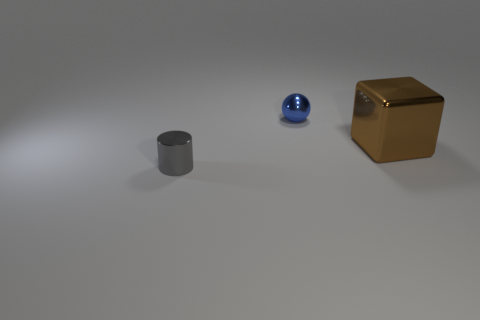Is there any other thing that has the same size as the brown shiny thing?
Provide a short and direct response. No. How many cylinders are either small gray objects or tiny yellow objects?
Provide a succinct answer. 1. The metal cube is what color?
Keep it short and to the point. Brown. How many things are metallic cubes or blue spheres?
Offer a very short reply. 2. There is a shiny object that is right of the metallic ball; what size is it?
Ensure brevity in your answer.  Large. How many objects are either small metallic objects in front of the small blue metallic ball or small objects in front of the tiny blue ball?
Your answer should be very brief. 1. What number of other things are the same color as the big block?
Provide a short and direct response. 0. Are there fewer small gray things to the left of the sphere than metallic things behind the gray shiny object?
Make the answer very short. Yes. Is the sphere the same color as the metallic block?
Your answer should be compact. No. There is a tiny gray thing that is made of the same material as the blue ball; what is its shape?
Provide a short and direct response. Cylinder. 